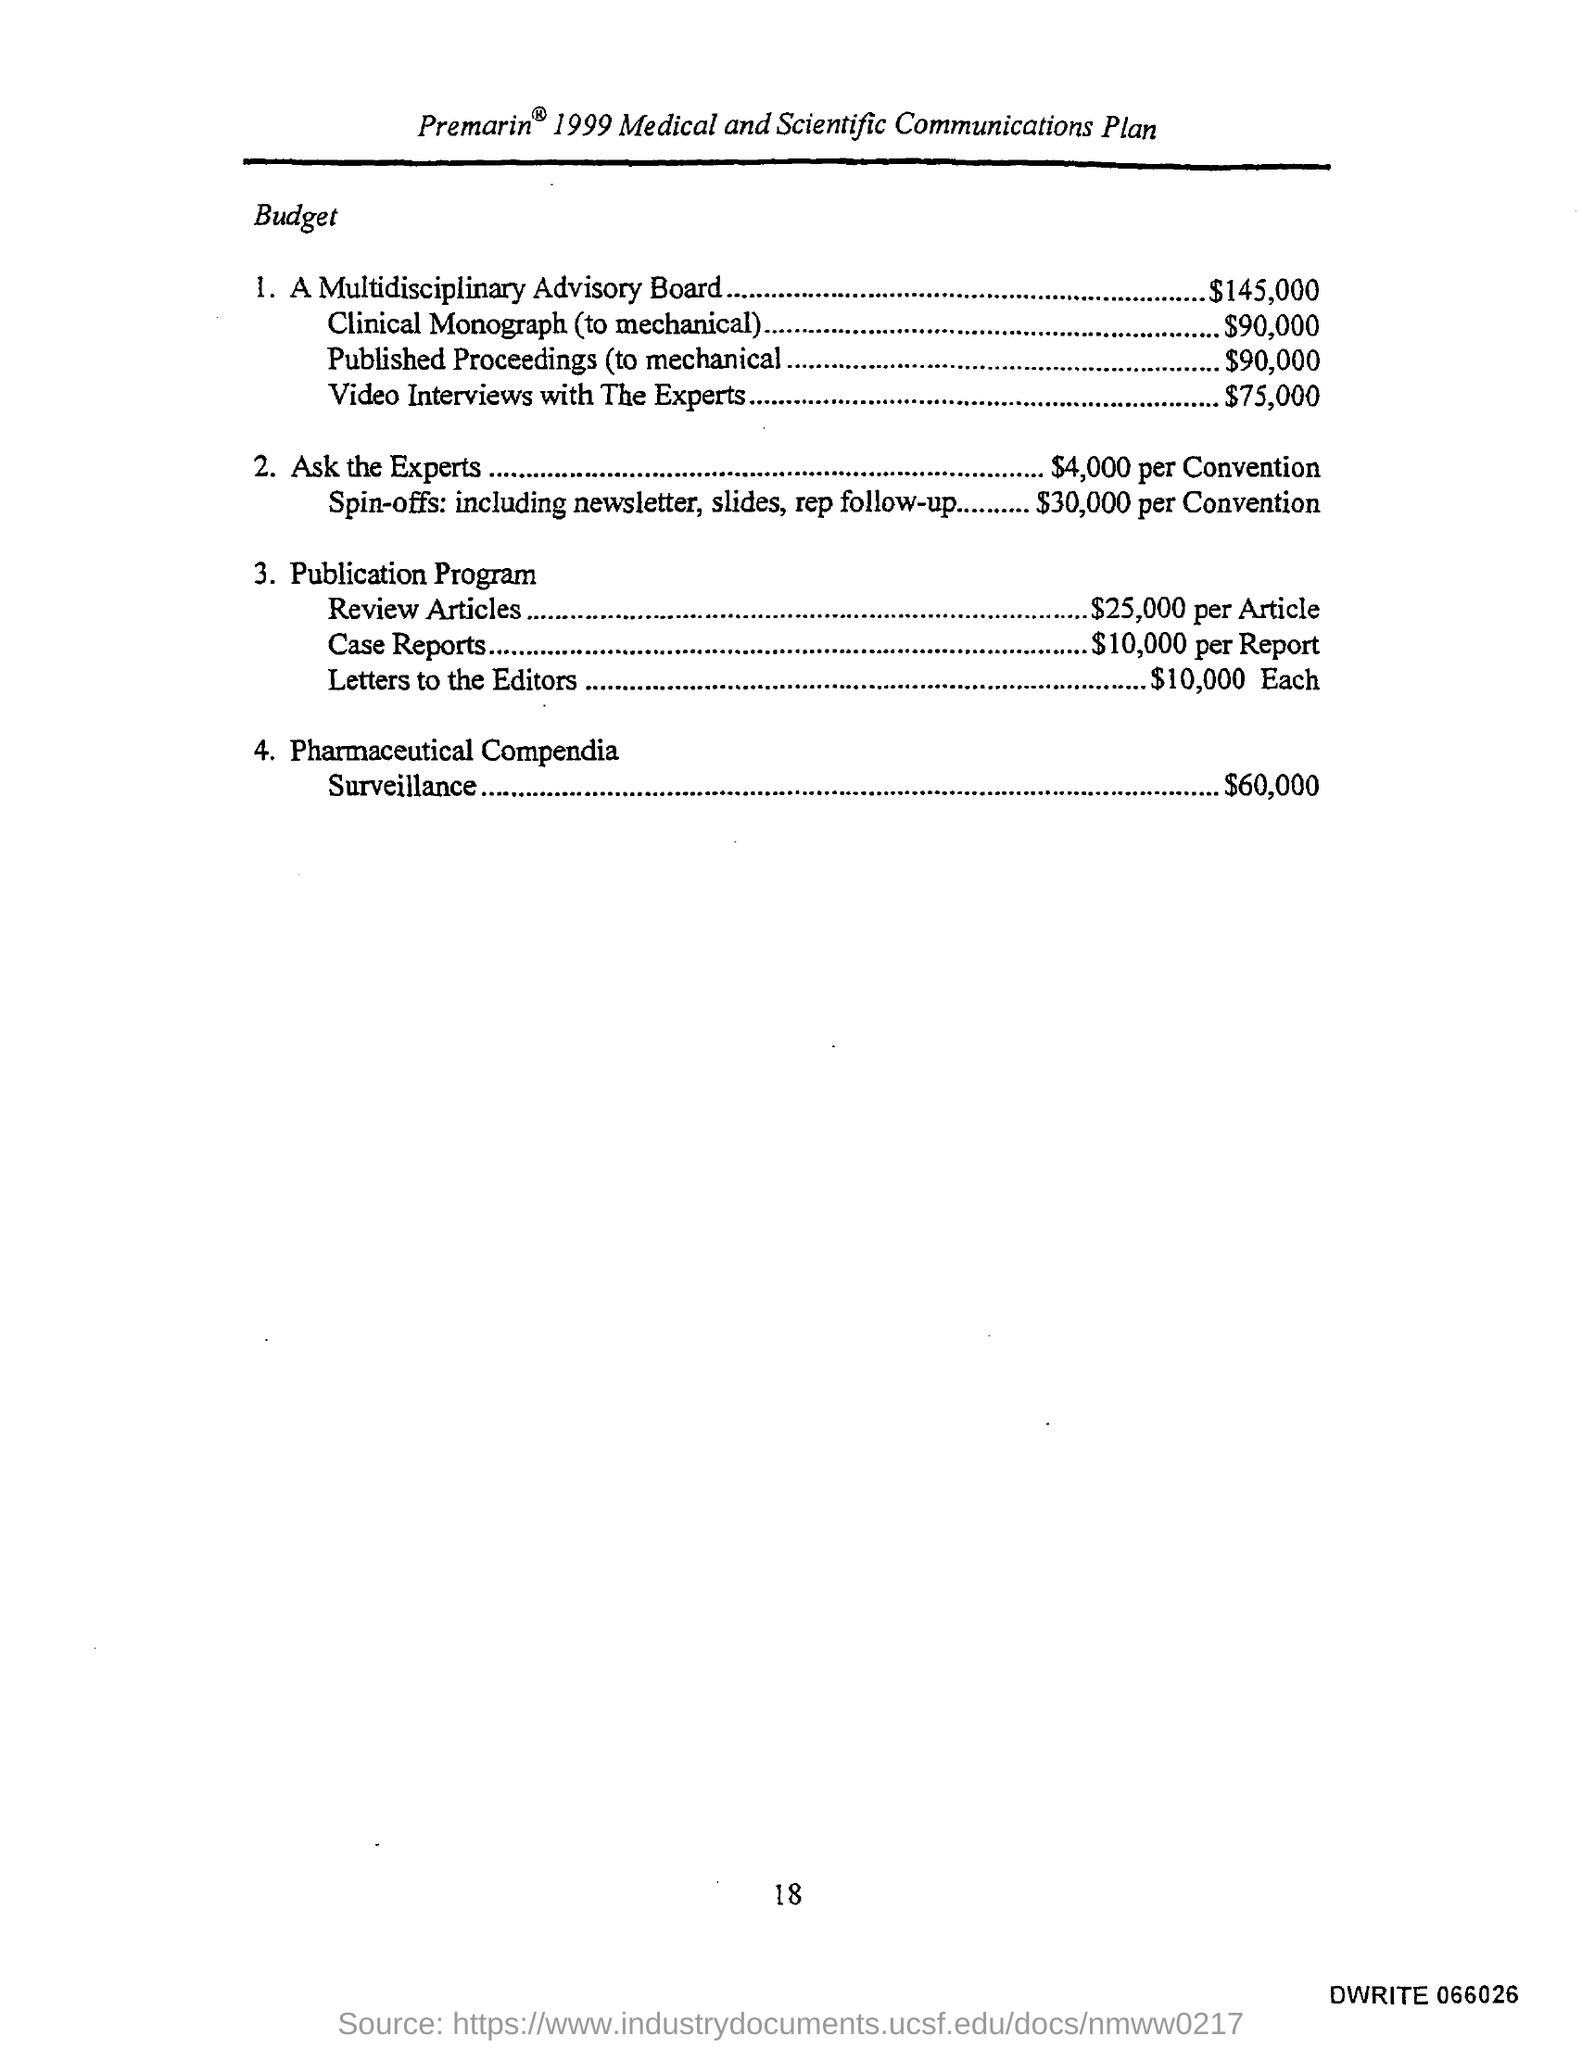Outline some significant characteristics in this image. The budget for "Ask the Experts" is $4000 per conversation, which provides a comprehensive solution for customers seeking expert advice. The estimated budget for the clinical monograph, to be produced using mechanical methods, is $90,000. The budget for published proceedings, specifically those related to mechanical engineering, is approximately $90,000. According to the budget for pharmaceutical compendia surveillance, the allocated amount is $60,000. The budget for video interviews with experts is $75,000. 